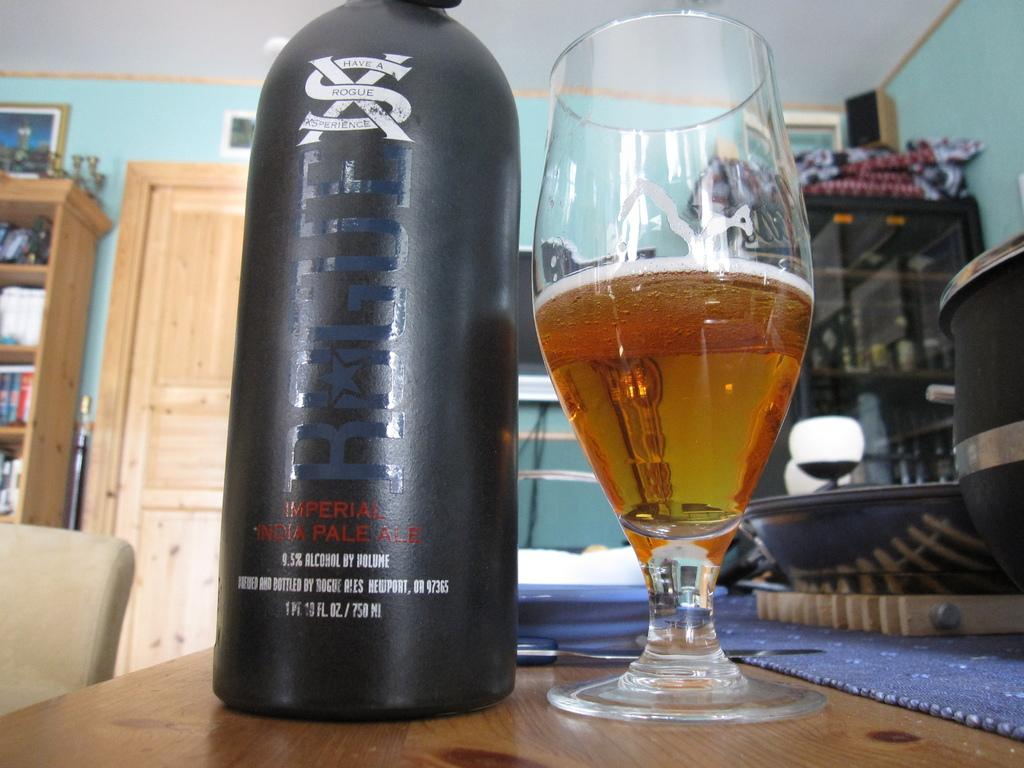<image>
Write a terse but informative summary of the picture. a close up of a glass and black can of Rouge Pale Ale 